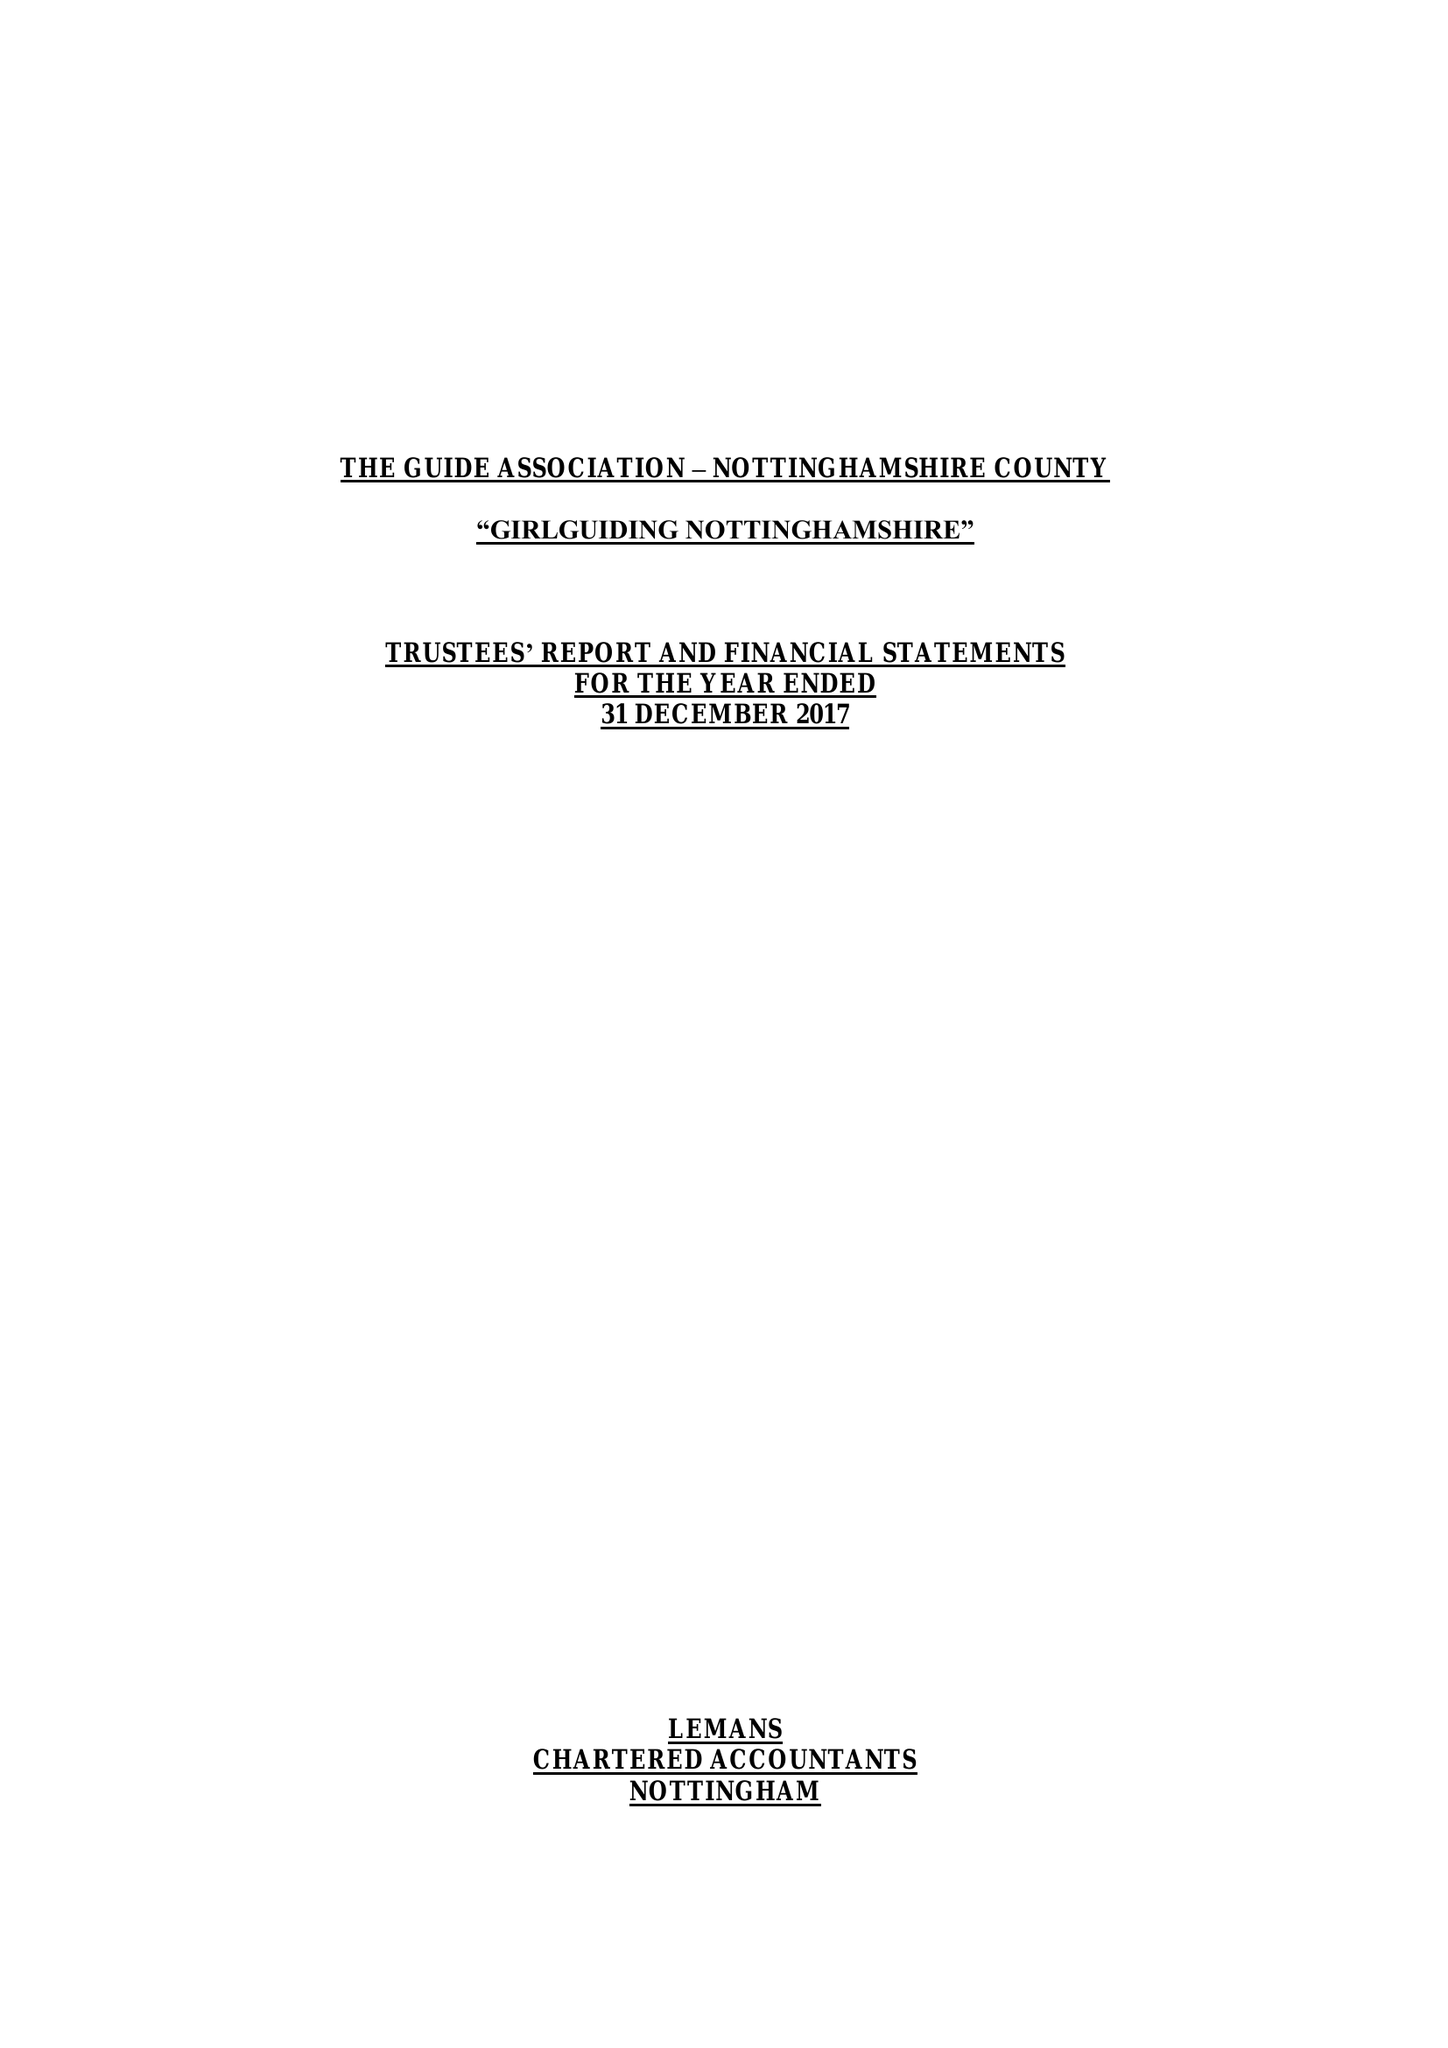What is the value for the address__postcode?
Answer the question using a single word or phrase. NG4 3DF 